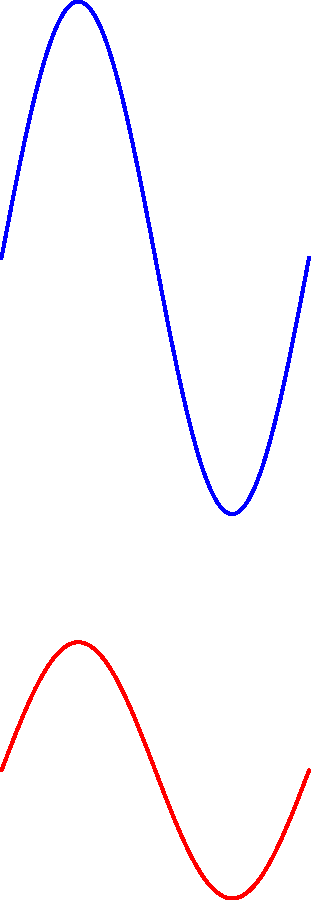As a retail store owner on Broadway, you've collected foot traffic data outside your store over a 12-hour period (9 AM to 9 PM) for both weekdays and weekends. The data is modeled by the following functions:

Weekday: $f(t) = 50 + 10\sin(\frac{\pi t}{6})$
Weekend: $g(t) = 30 + 5\sin(\frac{\pi t}{6})$

Where $t$ represents hours since 9 AM, and $f(t)$ and $g(t)$ represent the number of people passing by per minute.

Calculate the difference in total foot traffic between a weekday and a weekend during your store's operating hours. To solve this problem, we need to integrate both functions over the 12-hour period and then find the difference. Let's break it down step-by-step:

1. For weekdays, we need to calculate:
   $$\int_0^{12} (50 + 10\sin(\frac{\pi t}{6})) dt$$

2. For weekends, we need to calculate:
   $$\int_0^{12} (30 + 5\sin(\frac{\pi t}{6})) dt$$

3. Let's start with the weekday integral:
   $$\int_0^{12} (50 + 10\sin(\frac{\pi t}{6})) dt = 50t - \frac{60}{\pi}\cos(\frac{\pi t}{6}) \bigg|_0^{12}$$
   $$= (600 - \frac{60}{\pi}\cos(2\pi)) - (0 - \frac{60}{\pi}\cos(0))$$
   $$= 600 - \frac{60}{\pi} + \frac{60}{\pi} = 600$$

4. Now for the weekend integral:
   $$\int_0^{12} (30 + 5\sin(\frac{\pi t}{6})) dt = 30t - \frac{30}{\pi}\cos(\frac{\pi t}{6}) \bigg|_0^{12}$$
   $$= (360 - \frac{30}{\pi}\cos(2\pi)) - (0 - \frac{30}{\pi}\cos(0))$$
   $$= 360 - \frac{30}{\pi} + \frac{30}{\pi} = 360$$

5. The difference in total foot traffic is:
   Weekday total - Weekend total = 600 - 360 = 240

Therefore, there are 240 more people passing by the store during a weekday compared to a weekend over the 12-hour period.
Answer: 240 people 